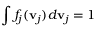<formula> <loc_0><loc_0><loc_500><loc_500>\int f _ { j } ( v _ { j } ) d v _ { j } = 1</formula> 